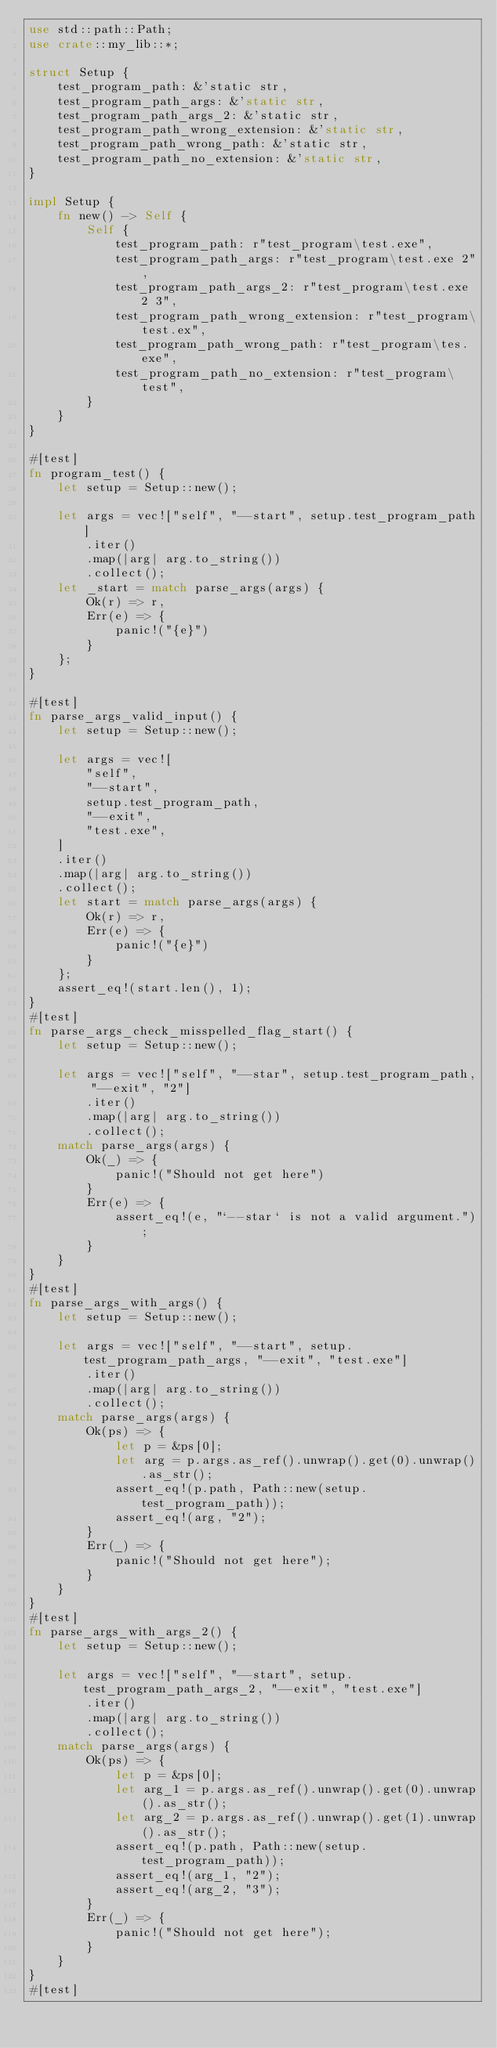<code> <loc_0><loc_0><loc_500><loc_500><_Rust_>use std::path::Path;
use crate::my_lib::*;

struct Setup {
    test_program_path: &'static str,
    test_program_path_args: &'static str,
    test_program_path_args_2: &'static str,
    test_program_path_wrong_extension: &'static str,
    test_program_path_wrong_path: &'static str,
    test_program_path_no_extension: &'static str,
}

impl Setup {
    fn new() -> Self {
        Self {
            test_program_path: r"test_program\test.exe",
            test_program_path_args: r"test_program\test.exe 2",
            test_program_path_args_2: r"test_program\test.exe 2 3",
            test_program_path_wrong_extension: r"test_program\test.ex",
            test_program_path_wrong_path: r"test_program\tes.exe",
            test_program_path_no_extension: r"test_program\test",
        }
    }
}

#[test]
fn program_test() {
    let setup = Setup::new();

    let args = vec!["self", "--start", setup.test_program_path]
        .iter()
        .map(|arg| arg.to_string())
        .collect();
    let _start = match parse_args(args) {
        Ok(r) => r,
        Err(e) => {
            panic!("{e}")
        }
    };
}

#[test]
fn parse_args_valid_input() {
    let setup = Setup::new();

    let args = vec![
        "self",
        "--start",
        setup.test_program_path,
        "--exit",
        "test.exe",
    ]
    .iter()
    .map(|arg| arg.to_string())
    .collect();
    let start = match parse_args(args) {
        Ok(r) => r,
        Err(e) => {
            panic!("{e}")
        }
    };
    assert_eq!(start.len(), 1);
}
#[test]
fn parse_args_check_misspelled_flag_start() {
    let setup = Setup::new();

    let args = vec!["self", "--star", setup.test_program_path, "--exit", "2"]
        .iter()
        .map(|arg| arg.to_string())
        .collect();
    match parse_args(args) {
        Ok(_) => {
            panic!("Should not get here")
        }
        Err(e) => {
            assert_eq!(e, "`--star` is not a valid argument.");
        }
    }
}
#[test]
fn parse_args_with_args() {
    let setup = Setup::new();

    let args = vec!["self", "--start", setup.test_program_path_args, "--exit", "test.exe"]
        .iter()
        .map(|arg| arg.to_string())
        .collect();
    match parse_args(args) {
        Ok(ps) => {
            let p = &ps[0];
            let arg = p.args.as_ref().unwrap().get(0).unwrap().as_str();
            assert_eq!(p.path, Path::new(setup.test_program_path));
            assert_eq!(arg, "2");
        }
        Err(_) => {
            panic!("Should not get here");
        }
    }
}
#[test]
fn parse_args_with_args_2() {
    let setup = Setup::new();

    let args = vec!["self", "--start", setup.test_program_path_args_2, "--exit", "test.exe"]
        .iter()
        .map(|arg| arg.to_string())
        .collect();
    match parse_args(args) {
        Ok(ps) => {
            let p = &ps[0];
            let arg_1 = p.args.as_ref().unwrap().get(0).unwrap().as_str();
            let arg_2 = p.args.as_ref().unwrap().get(1).unwrap().as_str();
            assert_eq!(p.path, Path::new(setup.test_program_path));
            assert_eq!(arg_1, "2");
            assert_eq!(arg_2, "3");
        }
        Err(_) => {
            panic!("Should not get here");
        }
    }
}
#[test]</code> 